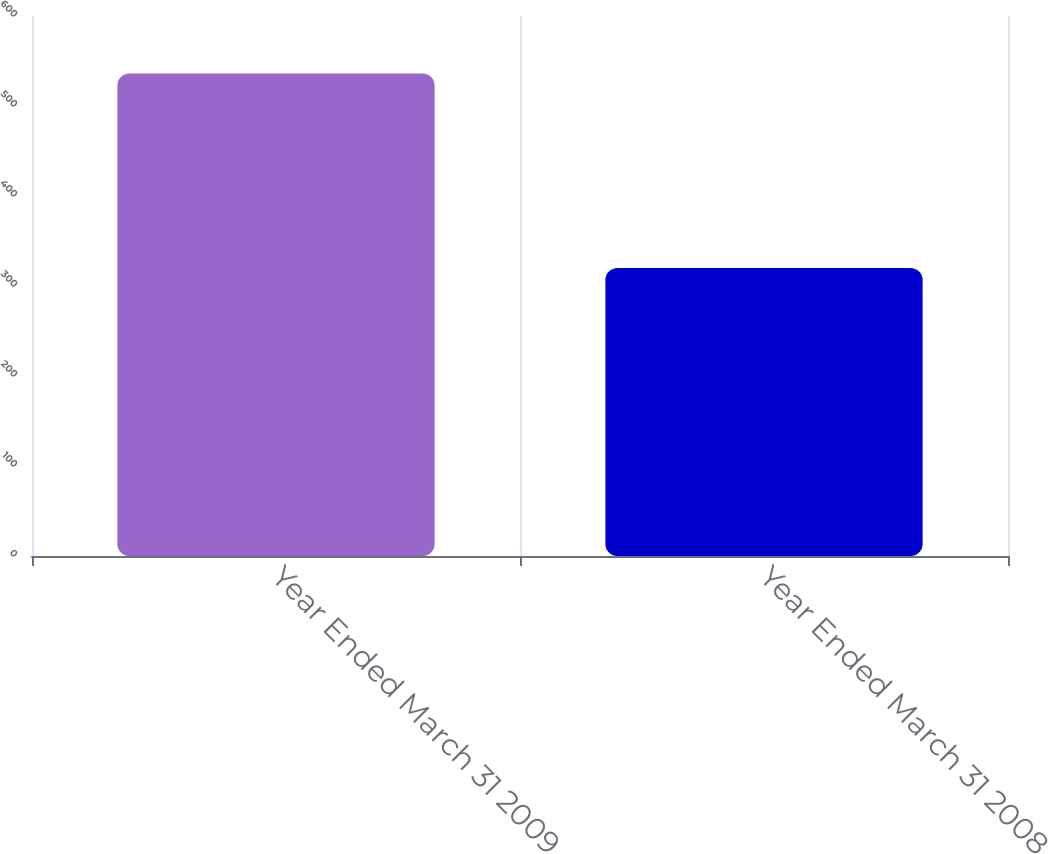Convert chart. <chart><loc_0><loc_0><loc_500><loc_500><bar_chart><fcel>Year Ended March 31 2009<fcel>Year Ended March 31 2008<nl><fcel>536<fcel>320<nl></chart> 